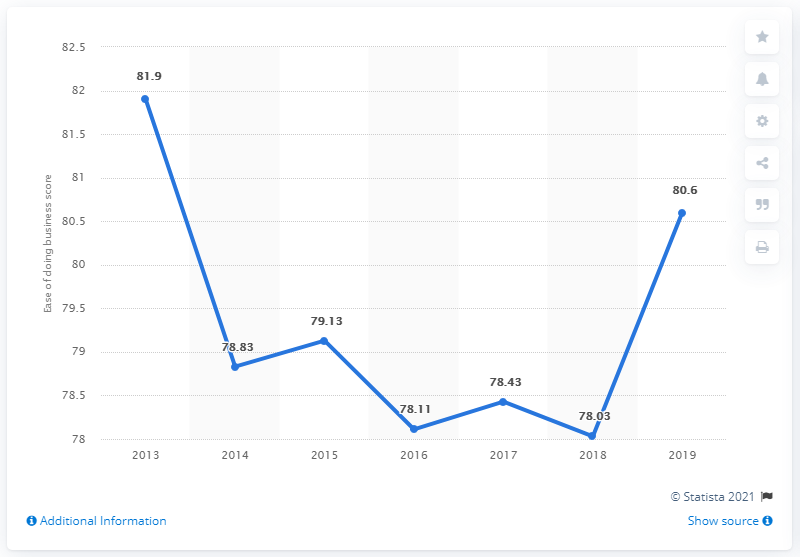Specify some key components in this picture. In 2019, Malaysia's ease of doing business score was 80.6 out of 100, indicating a relatively favorable business environment in the country. 